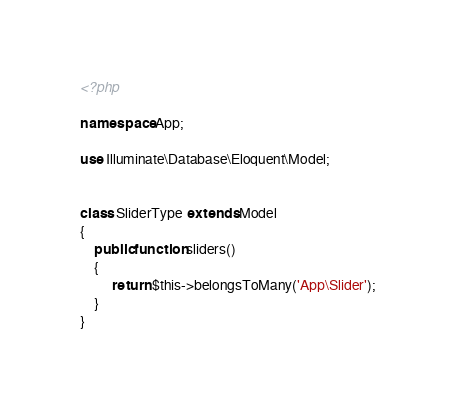<code> <loc_0><loc_0><loc_500><loc_500><_PHP_><?php

namespace App;

use Illuminate\Database\Eloquent\Model;


class SliderType extends Model
{
    public function sliders()
    {
         return $this->belongsToMany('App\Slider');
    }
}
</code> 